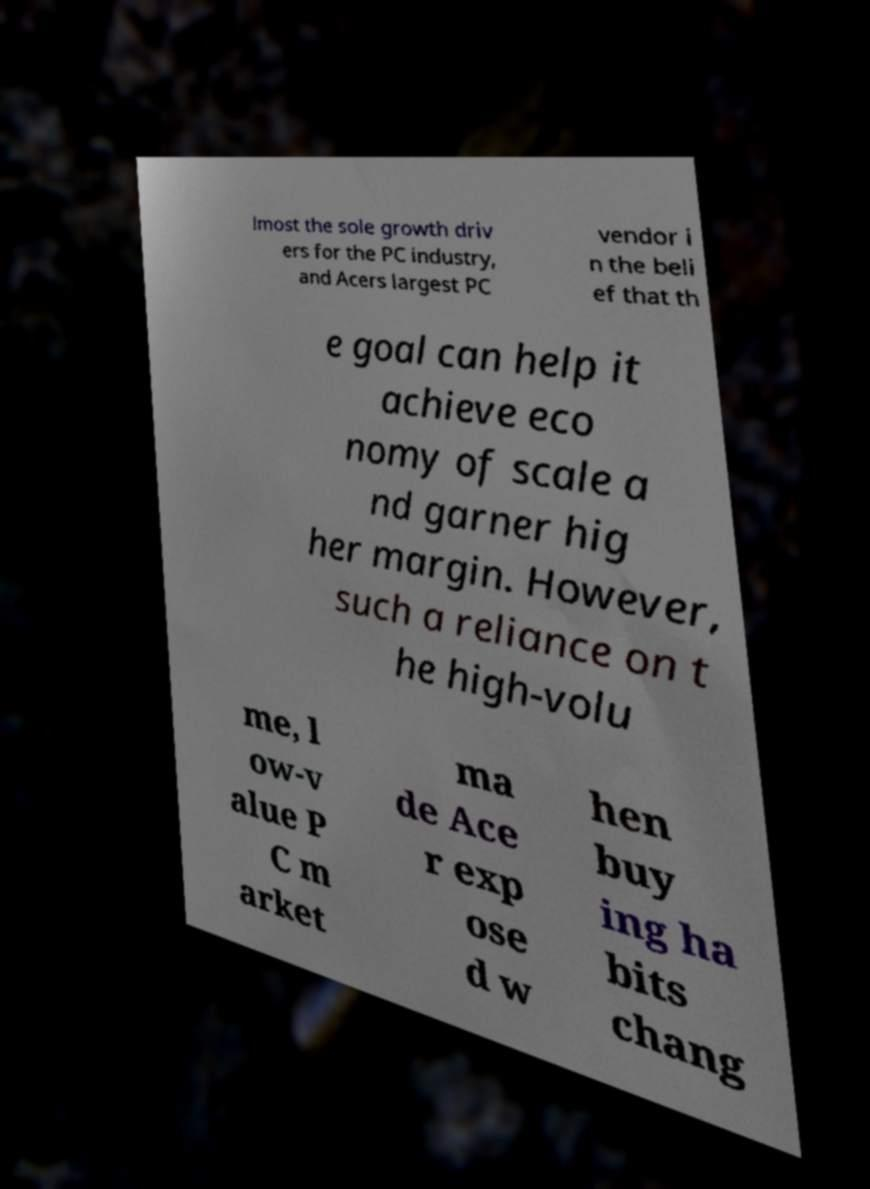Could you assist in decoding the text presented in this image and type it out clearly? lmost the sole growth driv ers for the PC industry, and Acers largest PC vendor i n the beli ef that th e goal can help it achieve eco nomy of scale a nd garner hig her margin. However, such a reliance on t he high-volu me, l ow-v alue P C m arket ma de Ace r exp ose d w hen buy ing ha bits chang 